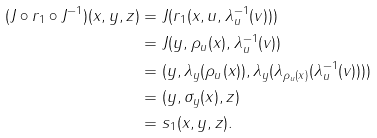<formula> <loc_0><loc_0><loc_500><loc_500>( J \circ r _ { 1 } \circ J ^ { - 1 } ) ( x , y , z ) & = J ( r _ { 1 } ( x , u , \lambda _ { u } ^ { - 1 } ( v ) ) ) \\ & = J ( y , \rho _ { u } ( x ) , \lambda _ { u } ^ { - 1 } ( v ) ) \\ & = ( y , \lambda _ { y } ( \rho _ { u } ( x ) ) , \lambda _ { y } ( \lambda _ { \rho _ { u } ( x ) } ( \lambda _ { u } ^ { - 1 } ( v ) ) ) ) \\ & = ( y , \sigma _ { y } ( x ) , z ) \\ & = s _ { 1 } ( x , y , z ) .</formula> 